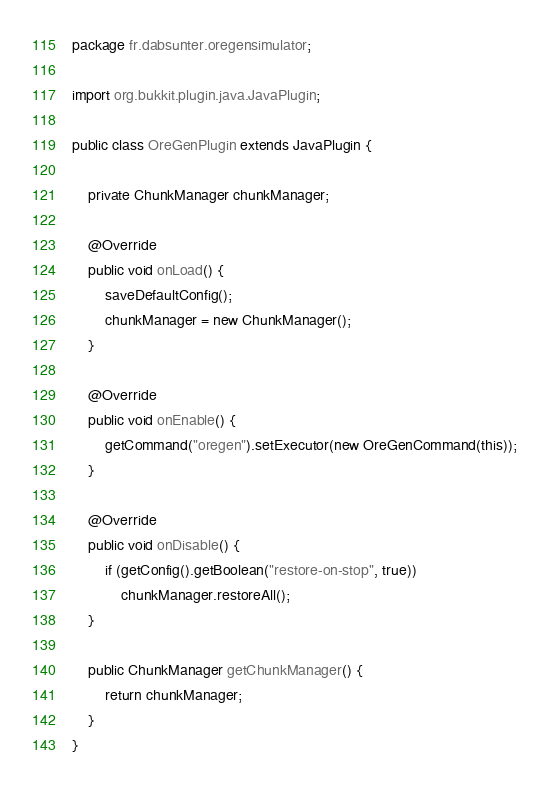Convert code to text. <code><loc_0><loc_0><loc_500><loc_500><_Java_>package fr.dabsunter.oregensimulator;

import org.bukkit.plugin.java.JavaPlugin;

public class OreGenPlugin extends JavaPlugin {

	private ChunkManager chunkManager;

	@Override
	public void onLoad() {
		saveDefaultConfig();
		chunkManager = new ChunkManager();
	}

	@Override
	public void onEnable() {
		getCommand("oregen").setExecutor(new OreGenCommand(this));
	}

	@Override
	public void onDisable() {
		if (getConfig().getBoolean("restore-on-stop", true)) 
			chunkManager.restoreAll();
	}

	public ChunkManager getChunkManager() {
		return chunkManager;
	}
}
</code> 